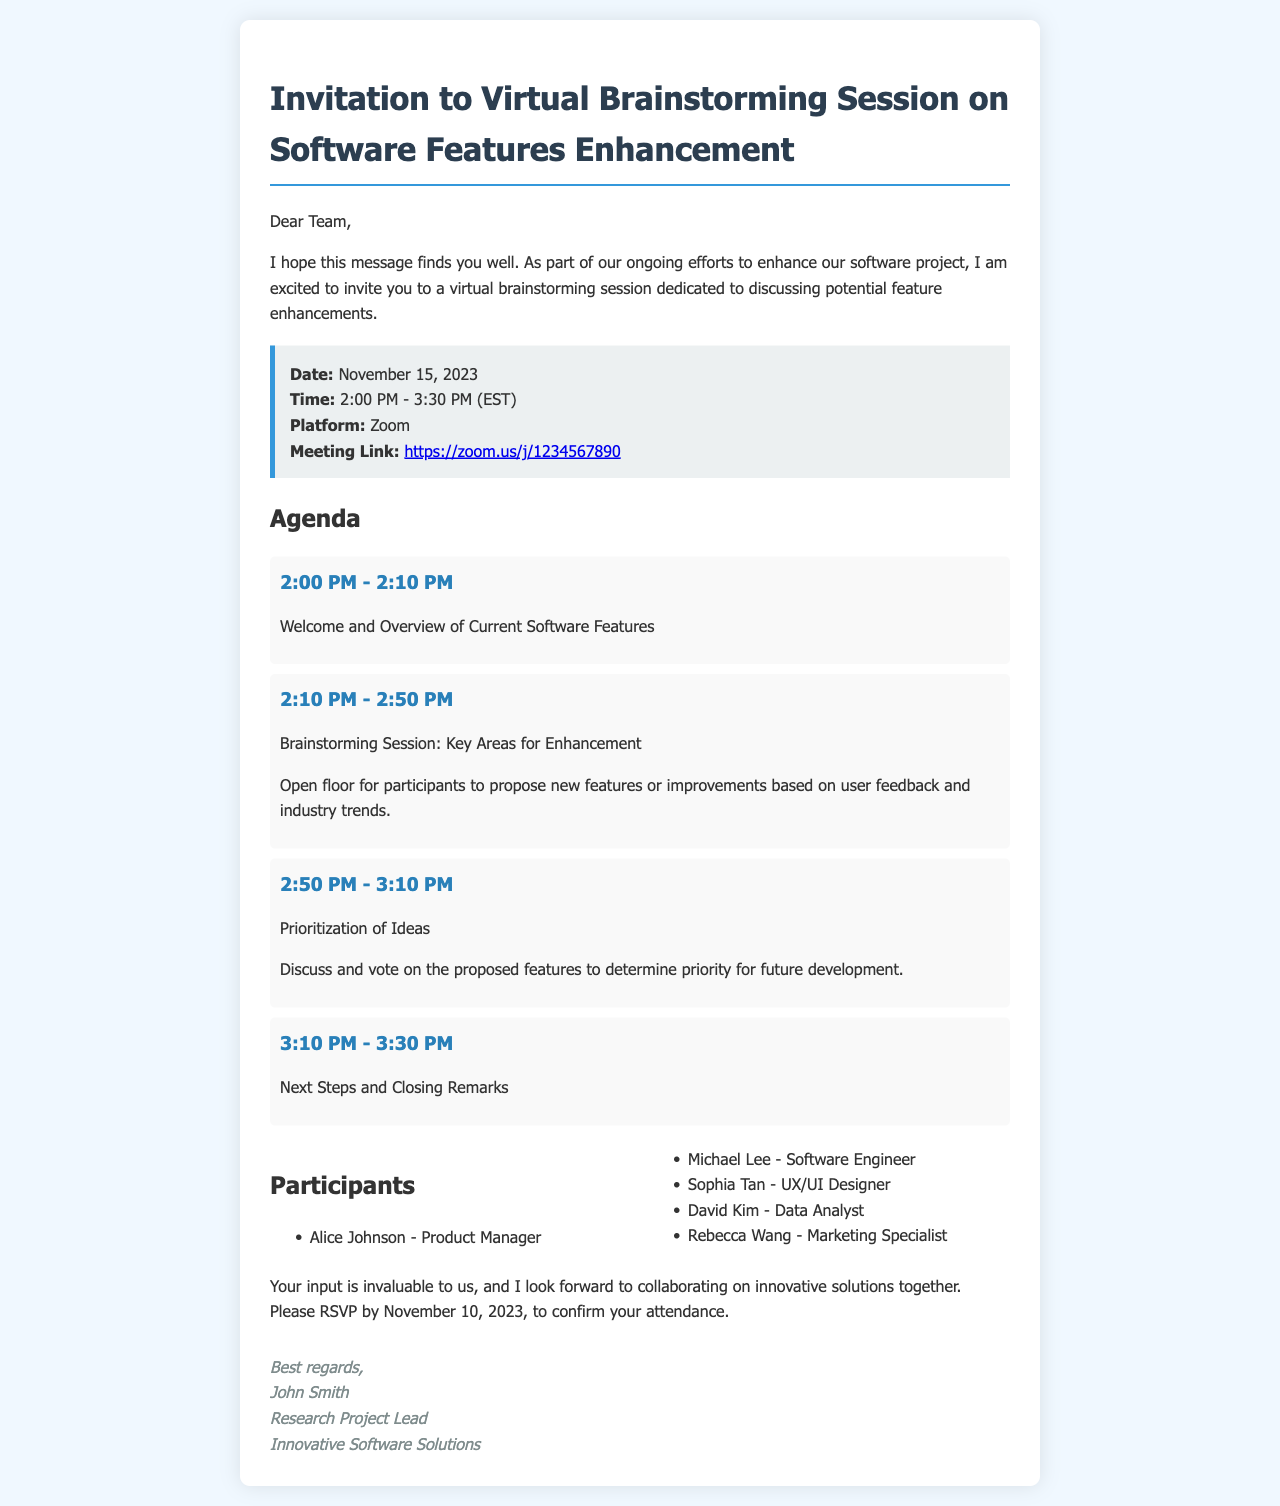What is the date of the brainstorming session? The date is explicitly stated in the document as November 15, 2023.
Answer: November 15, 2023 What time does the session start? The starting time is mentioned in the session details, which states it begins at 2:00 PM.
Answer: 2:00 PM Who is the Research Project Lead? The signature at the bottom of the document includes the name of the Research Project Lead, John Smith.
Answer: John Smith What platform will the session be held on? The session details clearly specify that the platform for the meeting is Zoom.
Answer: Zoom How long is the brainstorming session scheduled to last? The document provides a time frame, indicating the session lasts from 2:00 PM to 3:30 PM, which totals 1.5 hours.
Answer: 1.5 hours What is the main focus of the brainstorming session? The agenda highlights that the main focus of the brainstorming session is discussing potential feature enhancements.
Answer: Potential feature enhancements Who are the participants in the session? The participants are listed in the document, including names and their respective roles, such as Alice Johnson - Product Manager.
Answer: Alice Johnson - Product Manager When is the RSVP deadline? The document states that attendees should RSVP by November 10, 2023.
Answer: November 10, 2023 